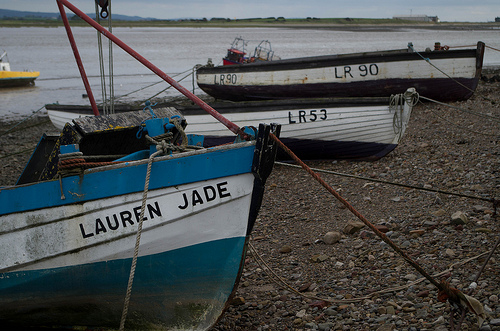What is the likely function of these boats? The boats are small fishing vessels, typically used for inshore fishing, given their size, design, and the presence of fishing gear. The name 'Lauren Jade' on the nearest boat adds a personal touch, indicating it might be privately owned and perhaps named after someone special to the owner. 